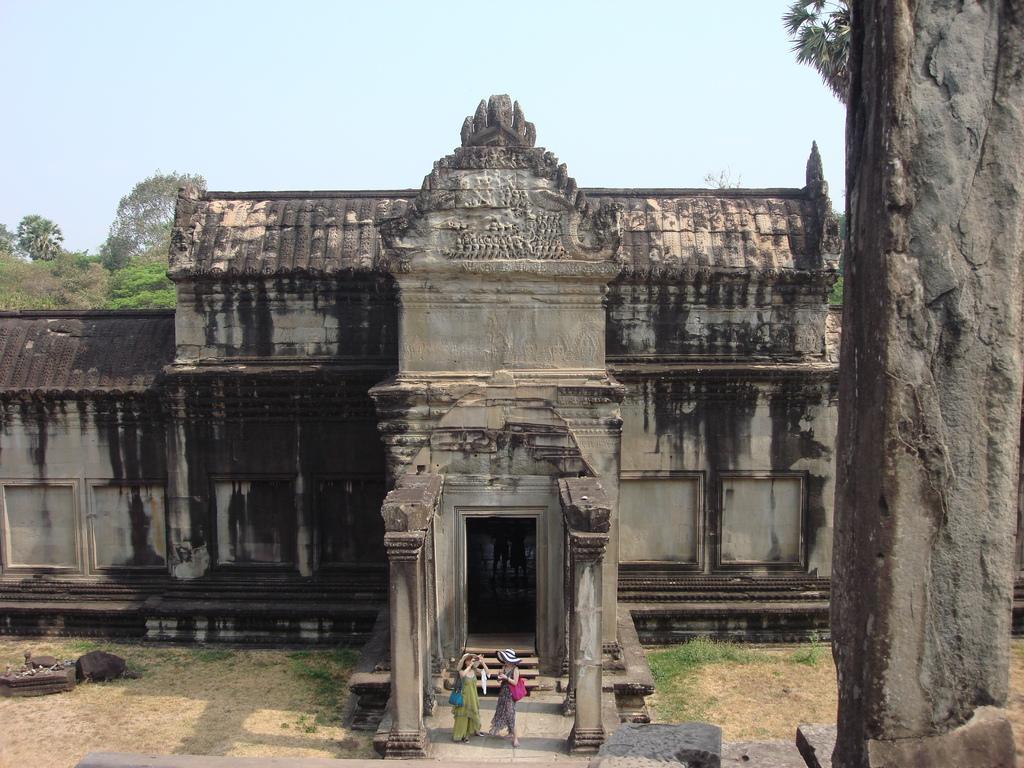How would you summarize this image in a sentence or two? In this picture there are two persons standing and there is a building and there are trees. At the top there is sky. At the bottom there is ground and there is grass. On the right side of the image there is a pillar. 